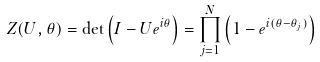<formula> <loc_0><loc_0><loc_500><loc_500>Z ( U , \theta ) = \det \left ( I - U e ^ { i \theta } \right ) = \prod _ { j = 1 } ^ { N } \left ( 1 - e ^ { i ( \theta - \theta _ { j } ) } \right )</formula> 